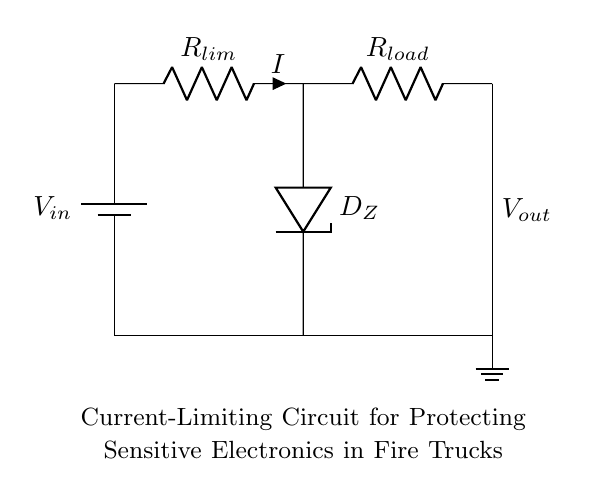What is the type of circuit shown? The circuit is a current-limiting circuit designed to protect sensitive electronic devices. This is evident from the presence of a current-limiting resistor and a Zener diode, which are typical components for this purpose.
Answer: current-limiting circuit What component limits the current? The component that limits the current is the current-limiting resistor, labeled as R. It is positioned in series to control the amount of current flowing through the circuit.
Answer: R What is the role of the Zener diode? The Zener diode, labeled as D_Z, regulates the voltage across the load resistor by maintaining a constant output voltage whenever the input voltage exceeds a certain value. This is crucial for protecting sensitive electronics.
Answer: voltage regulation What is connected to the load resistor? The load resistor, which is represented by R_load, is connected directly to the output of the circuit where the sensitive electronic devices are connected. This is indicated by the connection lines extending from the load resistor.
Answer: sensitive devices What is the input voltage source in the circuit? The input voltage source is represented by the battery symbol labeled as V_in, which provides the necessary voltage to the circuit for it to function.
Answer: V_in What happens if the current exceeds the limit? If the current exceeds the limit set by the current-limiting resistor, the Zener diode will conduct to maintain the output voltage, protecting the load from excessive current that could cause damage.
Answer: protection mechanism 